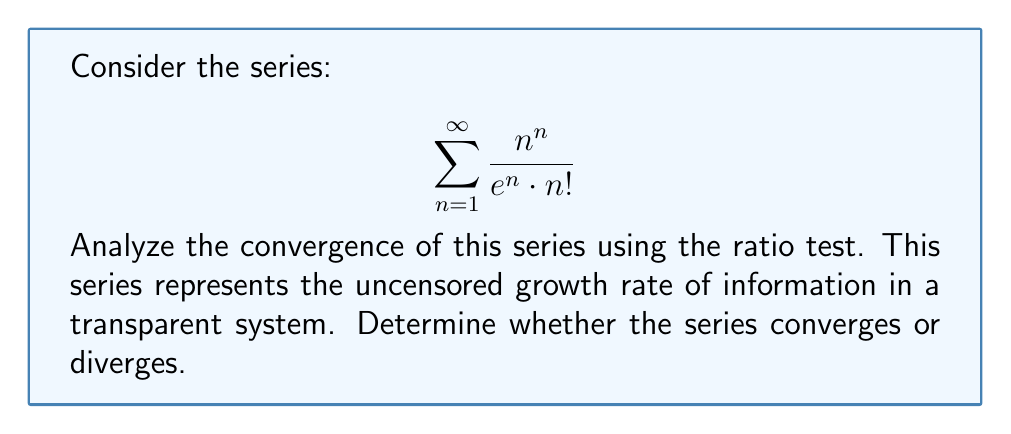Can you solve this math problem? Let's apply the ratio test to determine the convergence of the series:

1) Let $a_n = \frac{n^n}{e^n \cdot n!}$

2) We need to calculate $\lim_{n \to \infty} |\frac{a_{n+1}}{a_n}|$

3) $\frac{a_{n+1}}{a_n} = \frac{(n+1)^{n+1}}{e^{n+1} \cdot (n+1)!} \cdot \frac{e^n \cdot n!}{n^n}$

4) Simplify:
   $\frac{a_{n+1}}{a_n} = \frac{(n+1)^{n+1}}{e \cdot (n+1) \cdot n^n}$

5) $\frac{a_{n+1}}{a_n} = \frac{(n+1)^n \cdot (n+1)}{e \cdot (n+1) \cdot n^n} = \frac{(n+1)^n}{e \cdot n^n}$

6) Now, let's calculate the limit:
   $\lim_{n \to \infty} |\frac{a_{n+1}}{a_n}| = \lim_{n \to \infty} \frac{(n+1)^n}{e \cdot n^n}$

7) We can rewrite this as:
   $\lim_{n \to \infty} \frac{(n+1)^n}{e \cdot n^n} = \lim_{n \to \infty} \frac{1}{e} \cdot (1 + \frac{1}{n})^n$

8) We know that $\lim_{n \to \infty} (1 + \frac{1}{n})^n = e$

9) Therefore, $\lim_{n \to \infty} |\frac{a_{n+1}}{a_n}| = \frac{1}{e} \cdot e = 1$

10) According to the ratio test, when the limit equals 1, the test is inconclusive.

11) In this case, we need to use other methods to determine convergence. One can show that this series actually diverges by comparing it to the harmonic series, but that's beyond the scope of the ratio test.
Answer: Ratio test is inconclusive (limit = 1) 